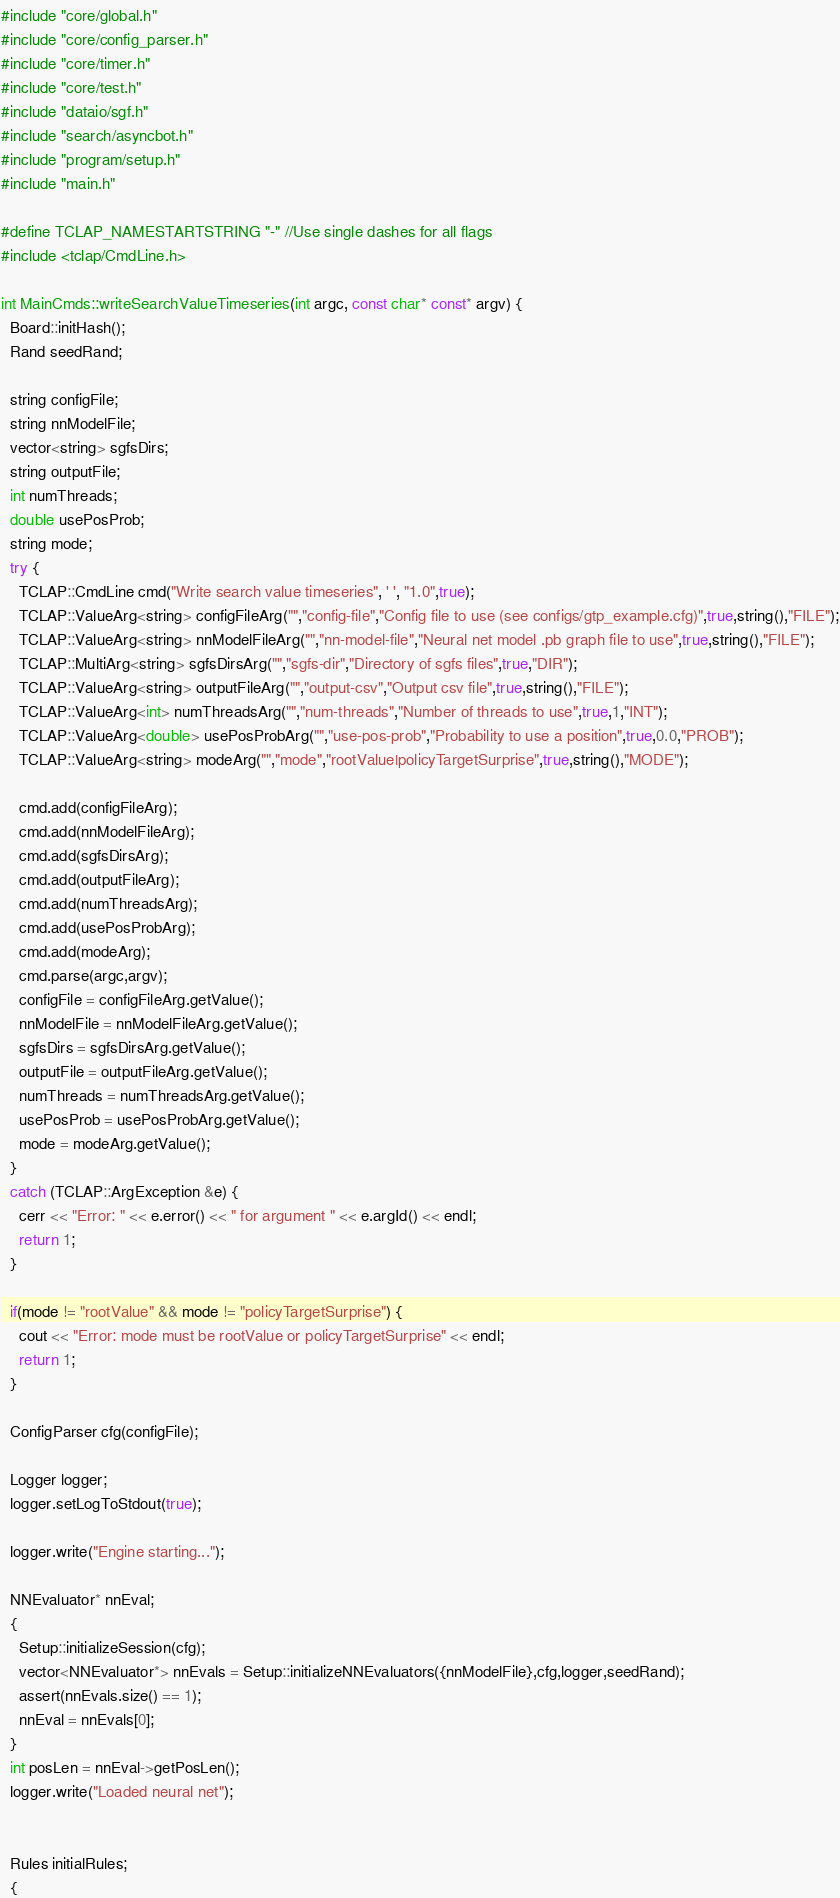Convert code to text. <code><loc_0><loc_0><loc_500><loc_500><_C++_>#include "core/global.h"
#include "core/config_parser.h"
#include "core/timer.h"
#include "core/test.h"
#include "dataio/sgf.h"
#include "search/asyncbot.h"
#include "program/setup.h"
#include "main.h"

#define TCLAP_NAMESTARTSTRING "-" //Use single dashes for all flags
#include <tclap/CmdLine.h>

int MainCmds::writeSearchValueTimeseries(int argc, const char* const* argv) {
  Board::initHash();
  Rand seedRand;

  string configFile;
  string nnModelFile;
  vector<string> sgfsDirs;
  string outputFile;
  int numThreads;
  double usePosProb;
  string mode;
  try {
    TCLAP::CmdLine cmd("Write search value timeseries", ' ', "1.0",true);
    TCLAP::ValueArg<string> configFileArg("","config-file","Config file to use (see configs/gtp_example.cfg)",true,string(),"FILE");
    TCLAP::ValueArg<string> nnModelFileArg("","nn-model-file","Neural net model .pb graph file to use",true,string(),"FILE");
    TCLAP::MultiArg<string> sgfsDirsArg("","sgfs-dir","Directory of sgfs files",true,"DIR");
    TCLAP::ValueArg<string> outputFileArg("","output-csv","Output csv file",true,string(),"FILE");
    TCLAP::ValueArg<int> numThreadsArg("","num-threads","Number of threads to use",true,1,"INT");
    TCLAP::ValueArg<double> usePosProbArg("","use-pos-prob","Probability to use a position",true,0.0,"PROB");
    TCLAP::ValueArg<string> modeArg("","mode","rootValue|policyTargetSurprise",true,string(),"MODE");

    cmd.add(configFileArg);
    cmd.add(nnModelFileArg);
    cmd.add(sgfsDirsArg);
    cmd.add(outputFileArg);
    cmd.add(numThreadsArg);
    cmd.add(usePosProbArg);
    cmd.add(modeArg);
    cmd.parse(argc,argv);
    configFile = configFileArg.getValue();
    nnModelFile = nnModelFileArg.getValue();
    sgfsDirs = sgfsDirsArg.getValue();
    outputFile = outputFileArg.getValue();
    numThreads = numThreadsArg.getValue();
    usePosProb = usePosProbArg.getValue();
    mode = modeArg.getValue();
  }
  catch (TCLAP::ArgException &e) {
    cerr << "Error: " << e.error() << " for argument " << e.argId() << endl;
    return 1;
  }

  if(mode != "rootValue" && mode != "policyTargetSurprise") {
    cout << "Error: mode must be rootValue or policyTargetSurprise" << endl;
    return 1;
  }

  ConfigParser cfg(configFile);

  Logger logger;
  logger.setLogToStdout(true);

  logger.write("Engine starting...");

  NNEvaluator* nnEval;
  {
    Setup::initializeSession(cfg);
    vector<NNEvaluator*> nnEvals = Setup::initializeNNEvaluators({nnModelFile},cfg,logger,seedRand);
    assert(nnEvals.size() == 1);
    nnEval = nnEvals[0];
  }
  int posLen = nnEval->getPosLen();
  logger.write("Loaded neural net");


  Rules initialRules;
  {</code> 